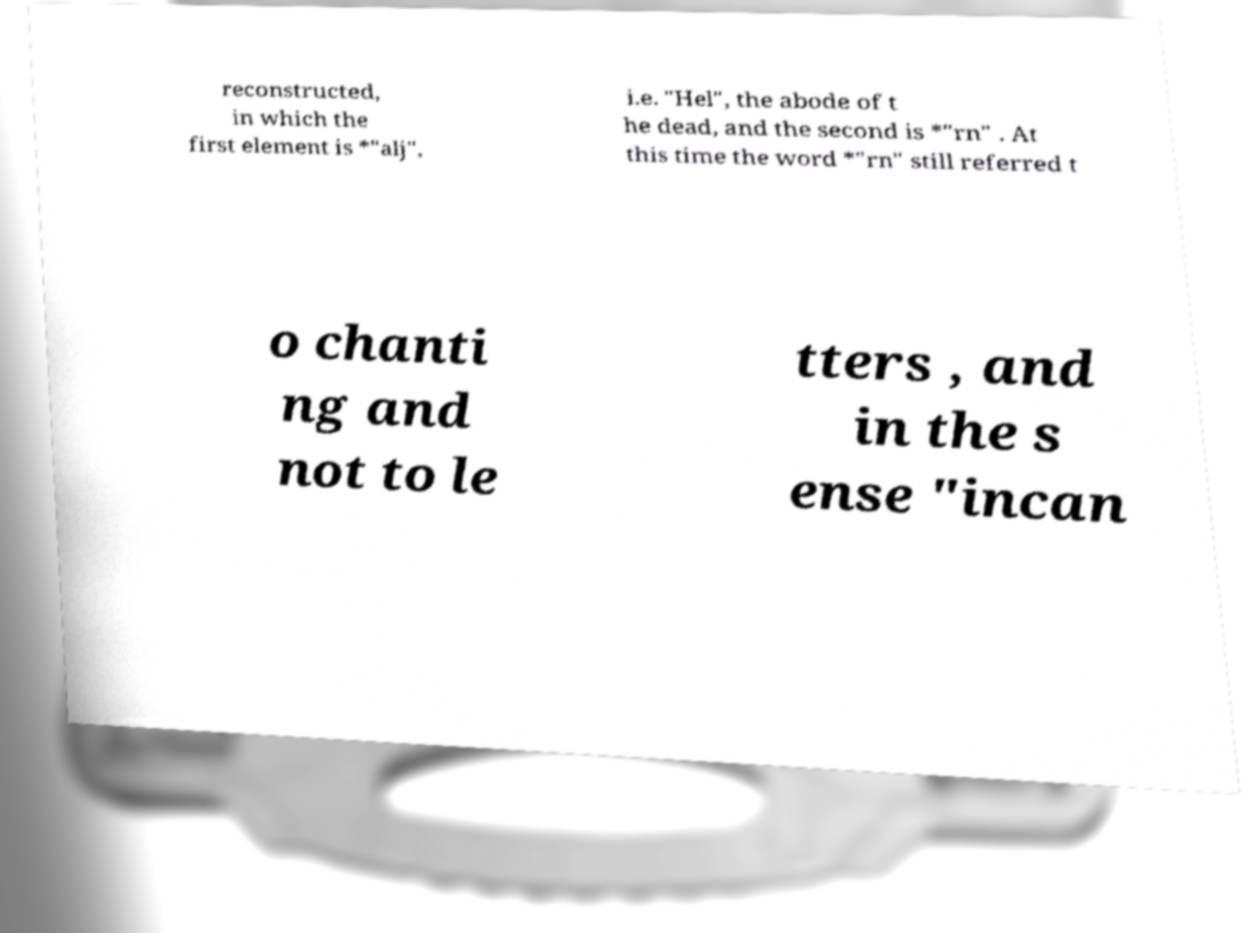Can you accurately transcribe the text from the provided image for me? reconstructed, in which the first element is *"alj", i.e. "Hel", the abode of t he dead, and the second is *"rn" . At this time the word *"rn" still referred t o chanti ng and not to le tters , and in the s ense "incan 